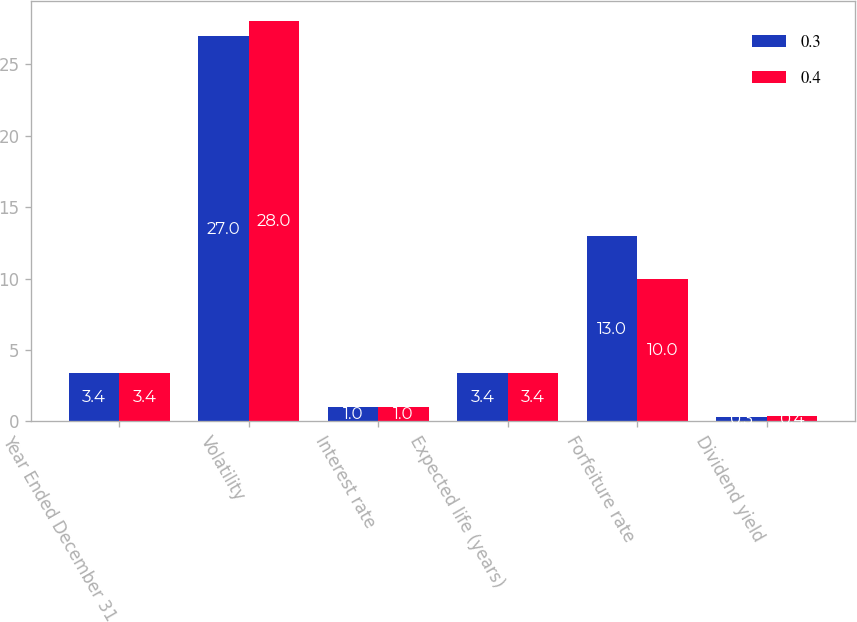Convert chart to OTSL. <chart><loc_0><loc_0><loc_500><loc_500><stacked_bar_chart><ecel><fcel>Year Ended December 31<fcel>Volatility<fcel>Interest rate<fcel>Expected life (years)<fcel>Forfeiture rate<fcel>Dividend yield<nl><fcel>0.3<fcel>3.4<fcel>27<fcel>1<fcel>3.4<fcel>13<fcel>0.3<nl><fcel>0.4<fcel>3.4<fcel>28<fcel>1<fcel>3.4<fcel>10<fcel>0.4<nl></chart> 